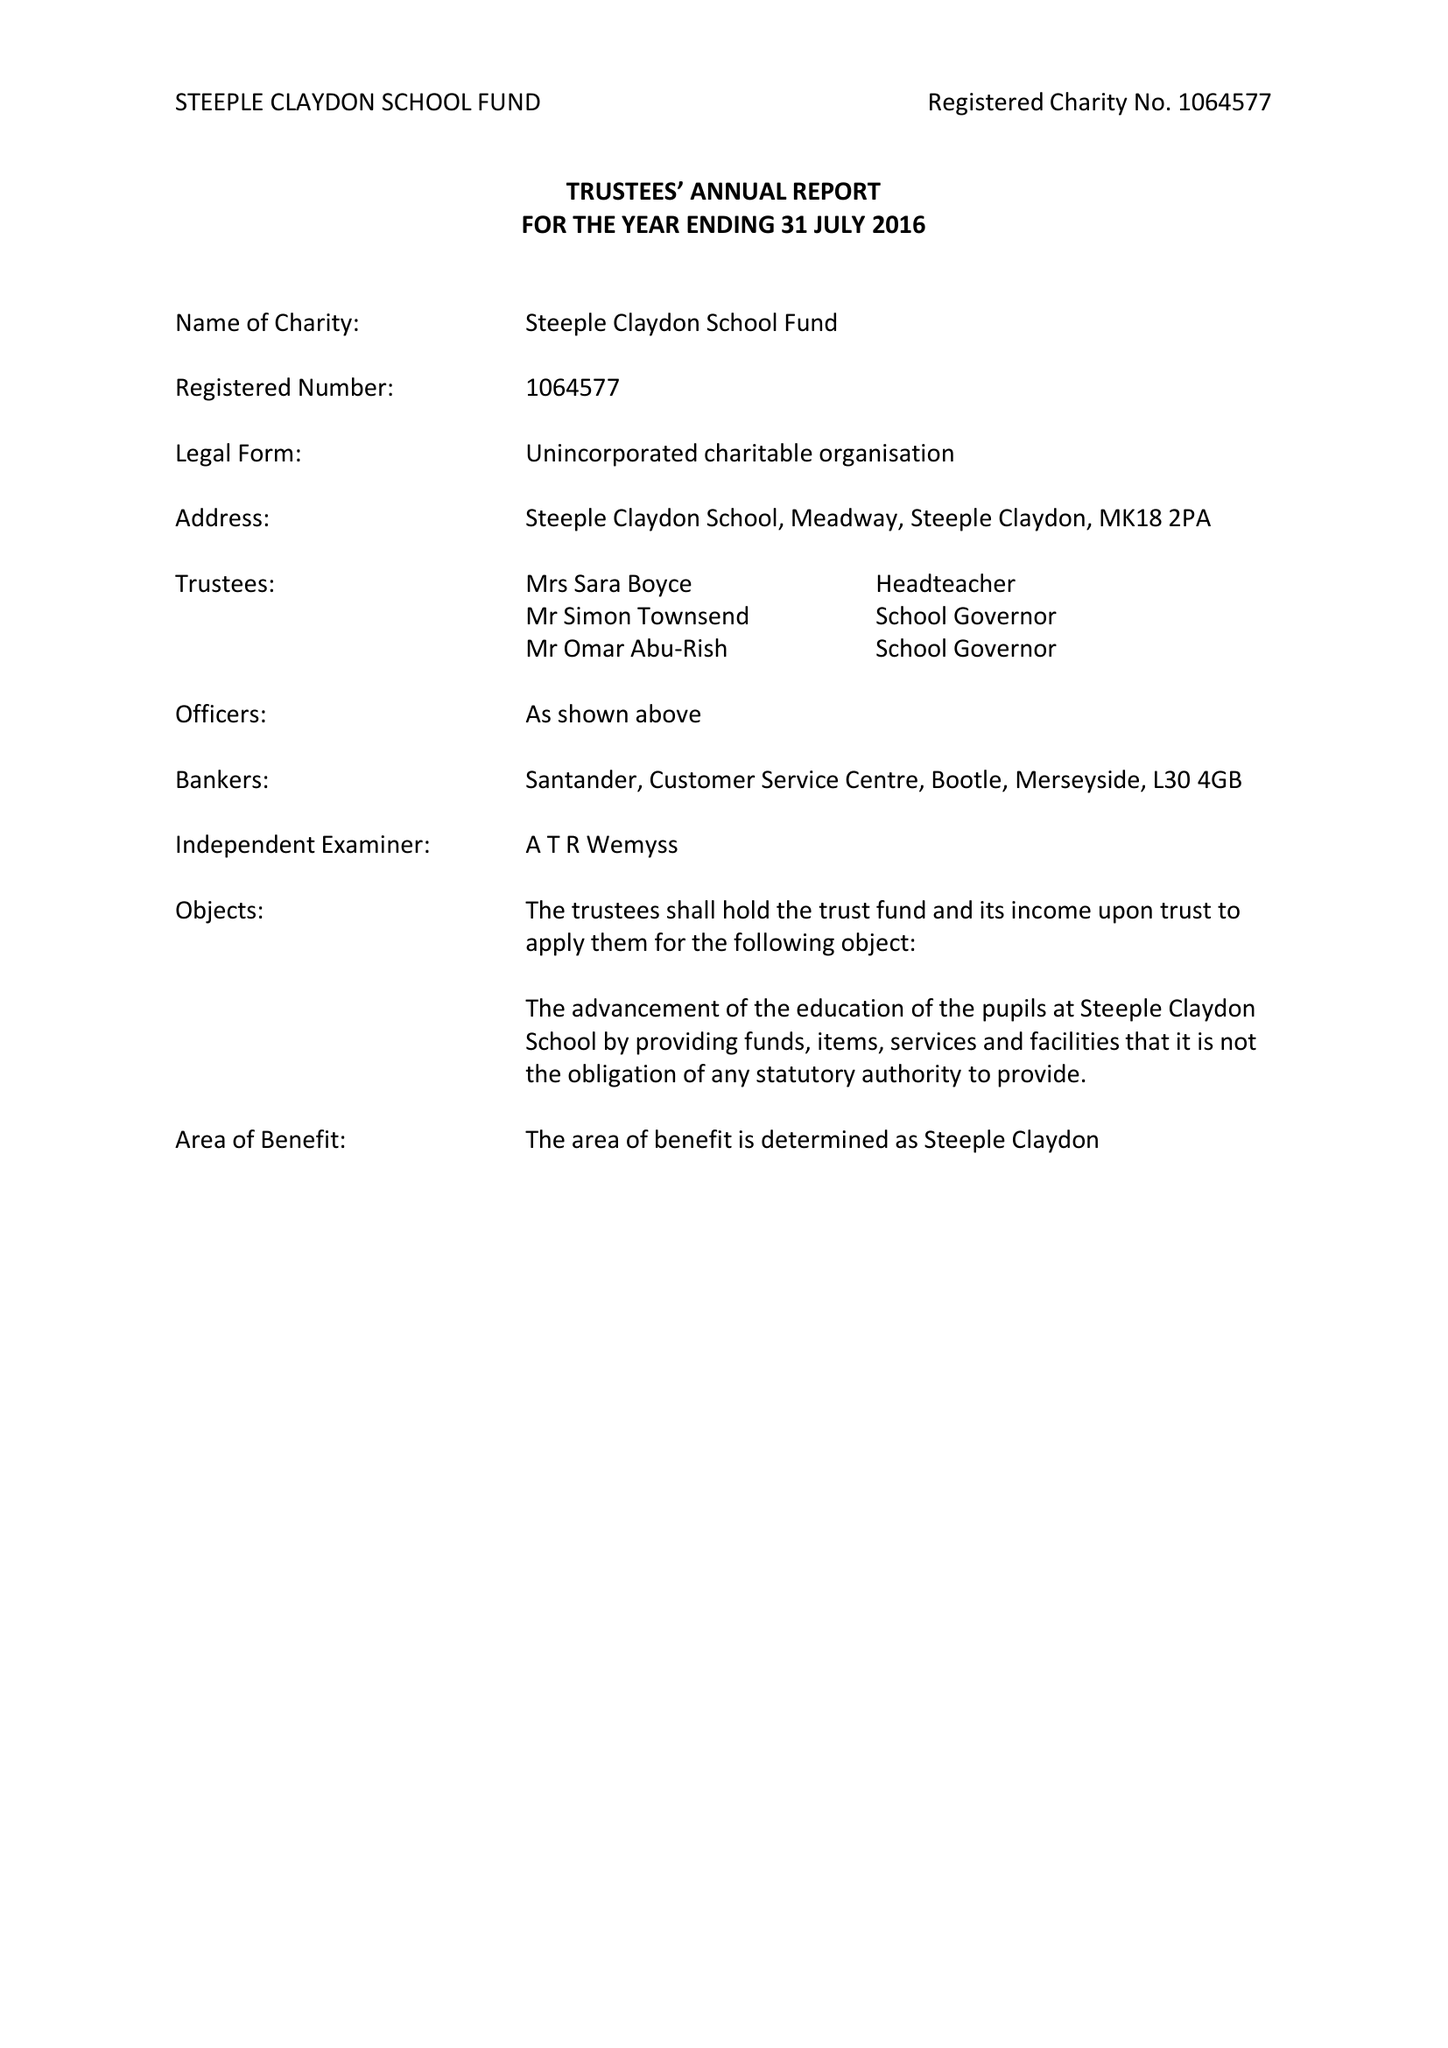What is the value for the address__post_town?
Answer the question using a single word or phrase. BUCKINGHAM 